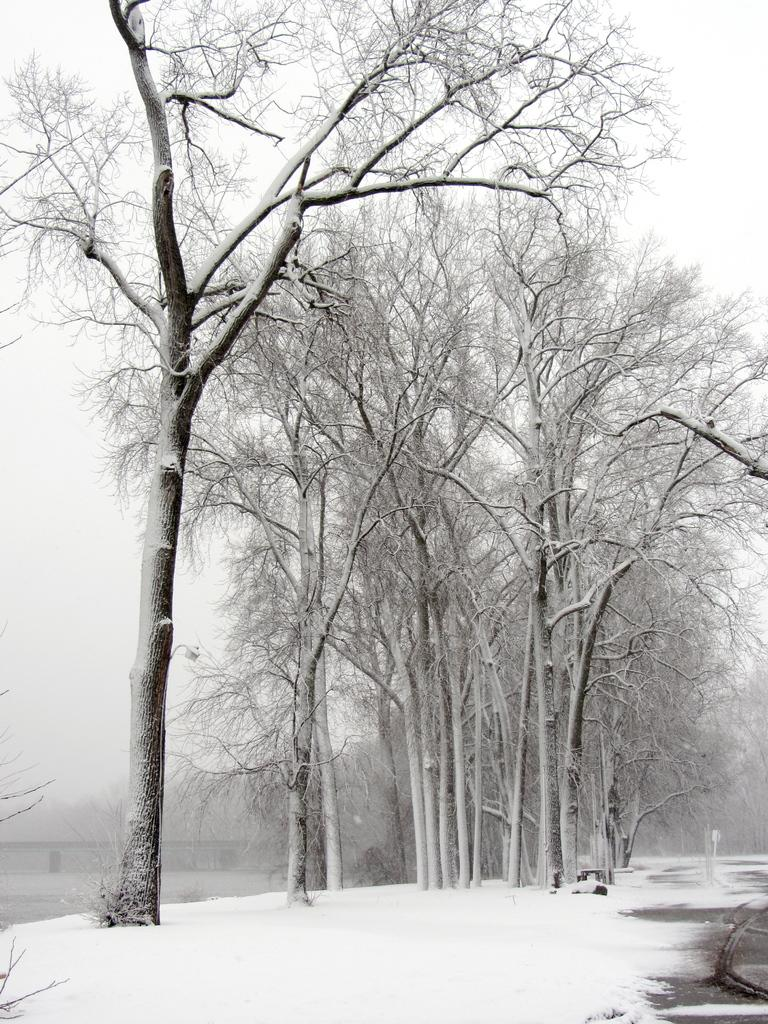What type of vegetation is present in the image? There are trees in the image. What is the condition of the trees in the image? The trees have no leaves and are covered with snow. Can you describe the background of the image? There are other objects in the background of the image. What type of harbor can be seen in the image? There is no harbor present in the image; it features trees covered with snow. What type of stage is visible in the image? There is no stage present in the image; it features trees covered with snow. 